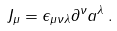<formula> <loc_0><loc_0><loc_500><loc_500>J _ { \mu } = \epsilon _ { \mu \nu \lambda } \partial ^ { \nu } a ^ { \lambda } \, .</formula> 